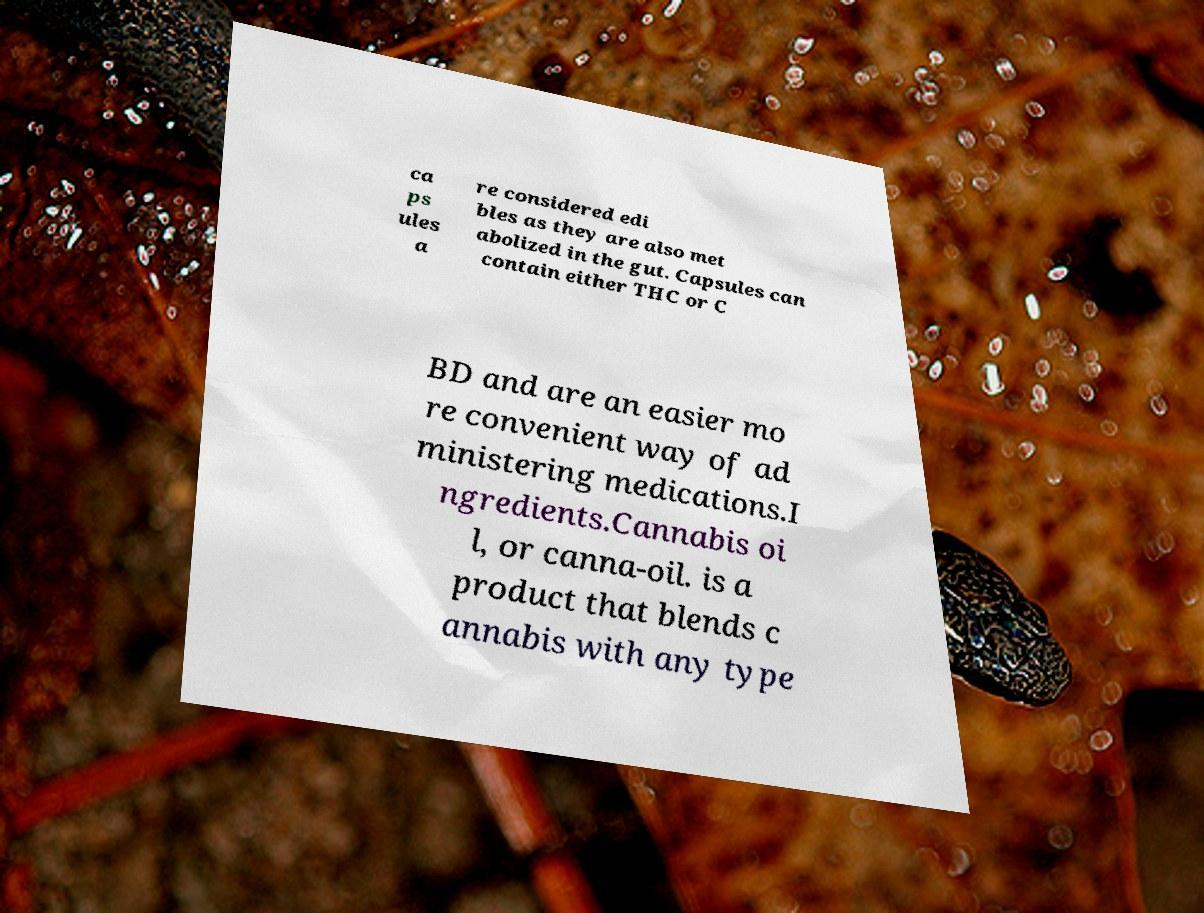Please identify and transcribe the text found in this image. ca ps ules a re considered edi bles as they are also met abolized in the gut. Capsules can contain either THC or C BD and are an easier mo re convenient way of ad ministering medications.I ngredients.Cannabis oi l, or canna-oil. is a product that blends c annabis with any type 